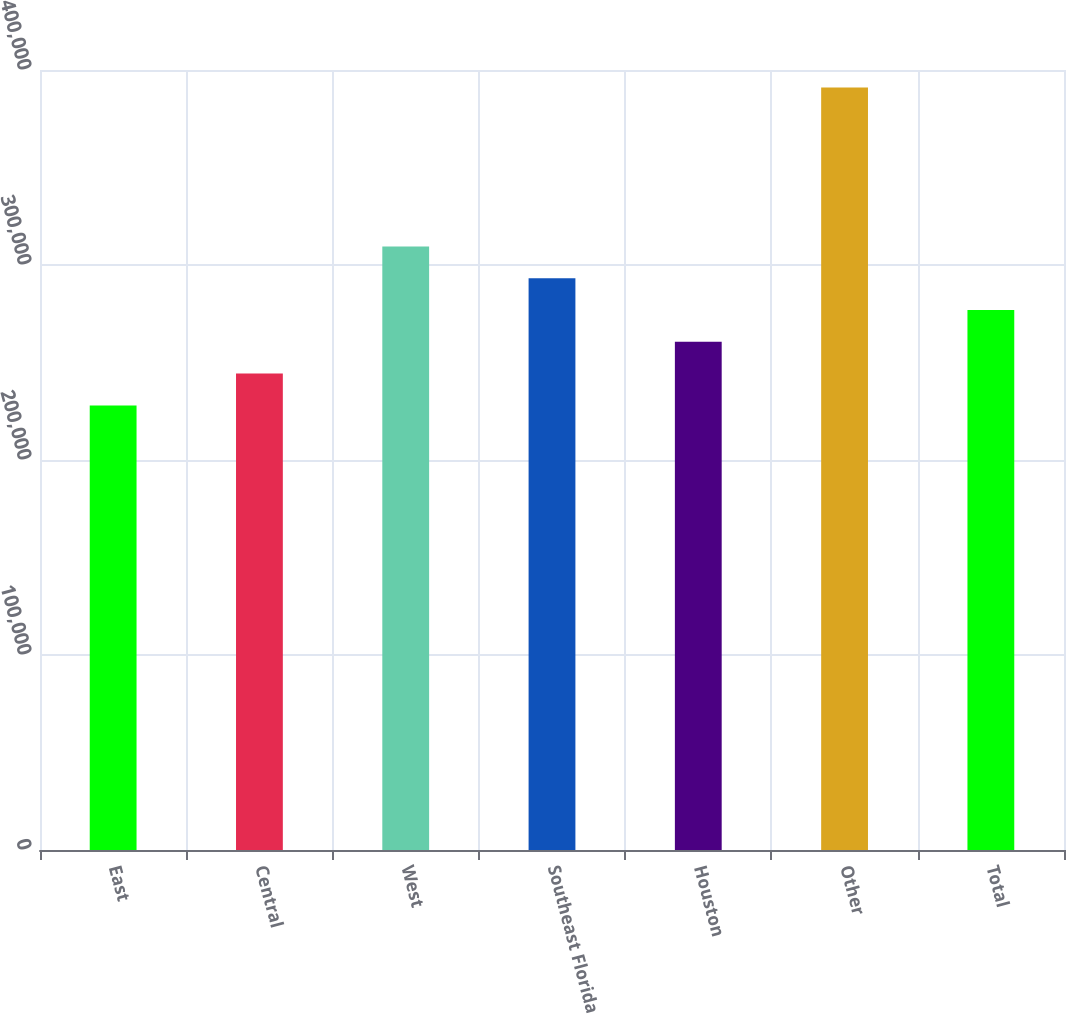Convert chart. <chart><loc_0><loc_0><loc_500><loc_500><bar_chart><fcel>East<fcel>Central<fcel>West<fcel>Southeast Florida<fcel>Houston<fcel>Other<fcel>Total<nl><fcel>228000<fcel>244300<fcel>309500<fcel>293200<fcel>260600<fcel>391000<fcel>276900<nl></chart> 